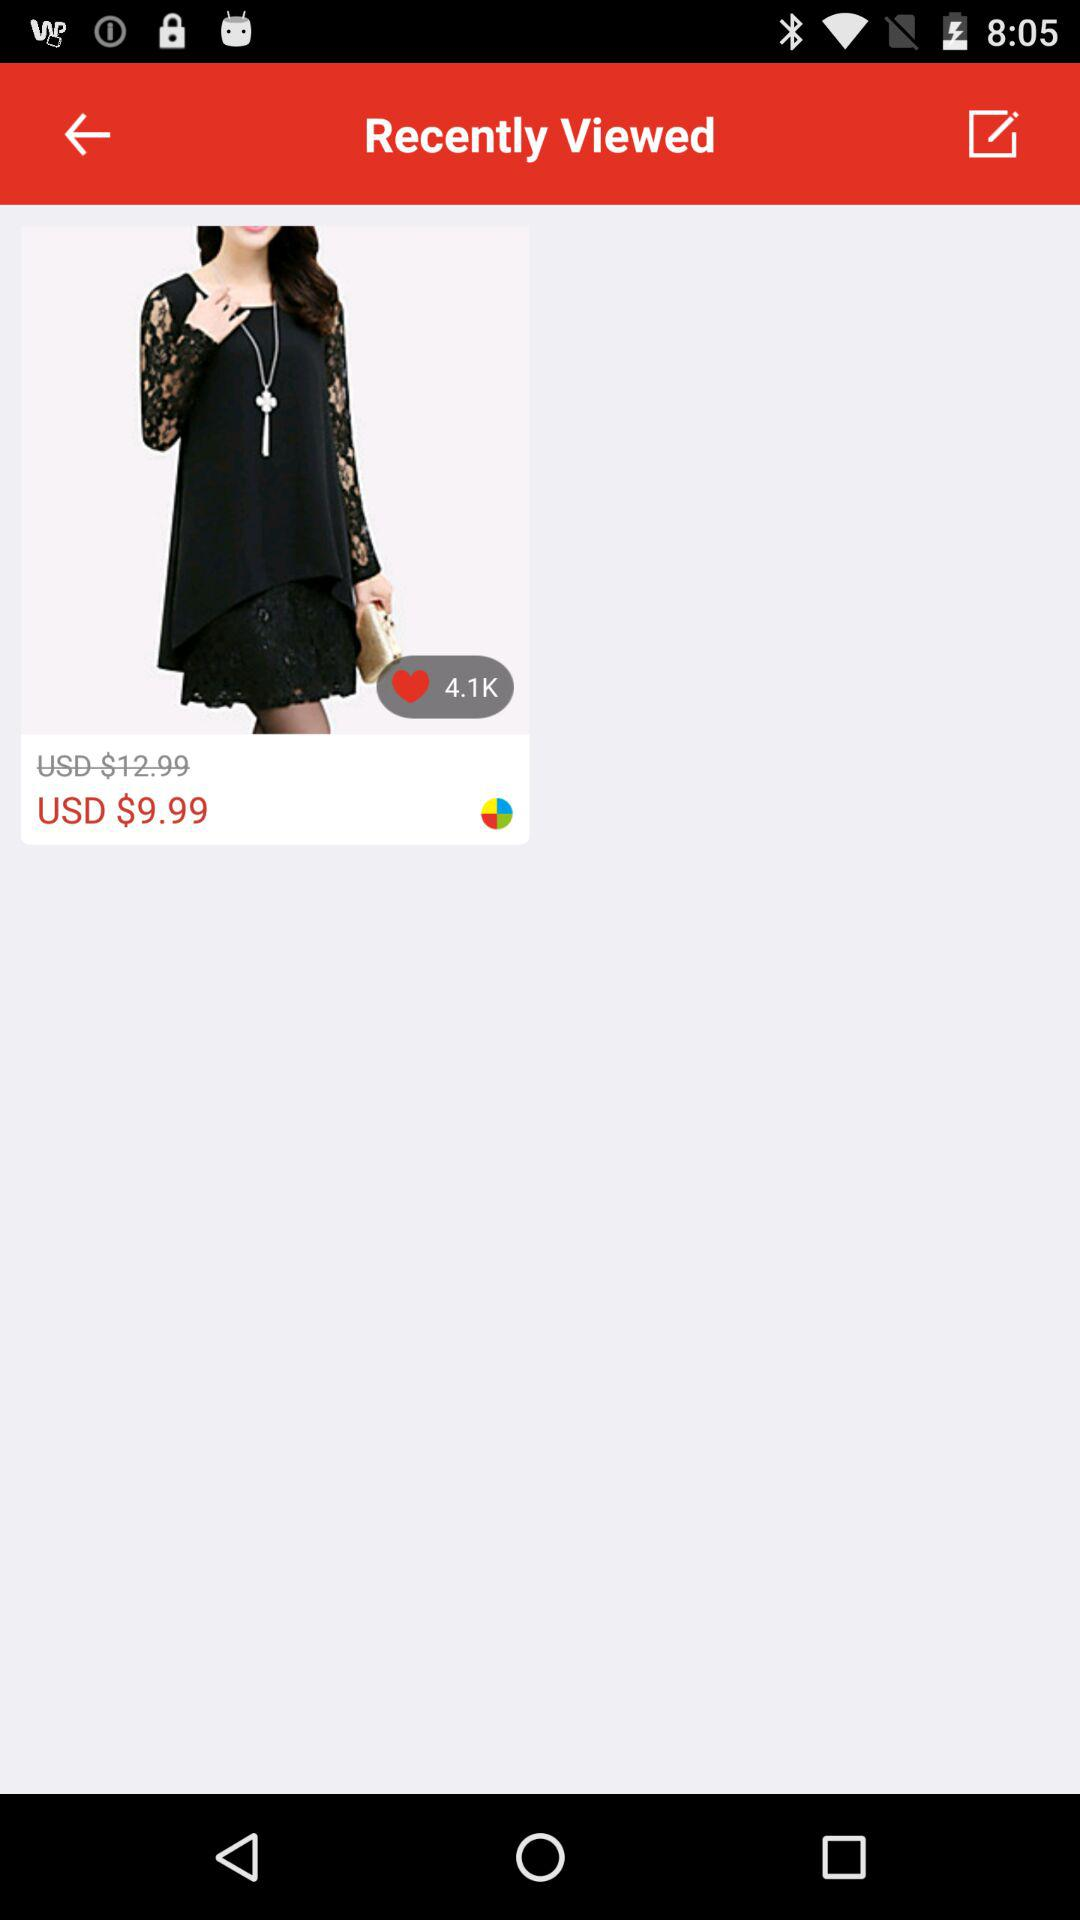How much more expensive is the product than the sale price?
Answer the question using a single word or phrase. 3 